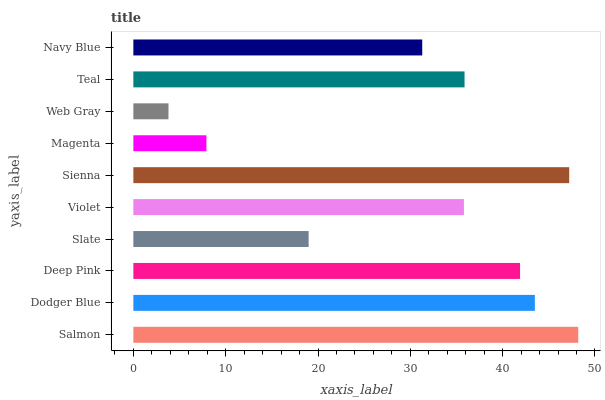Is Web Gray the minimum?
Answer yes or no. Yes. Is Salmon the maximum?
Answer yes or no. Yes. Is Dodger Blue the minimum?
Answer yes or no. No. Is Dodger Blue the maximum?
Answer yes or no. No. Is Salmon greater than Dodger Blue?
Answer yes or no. Yes. Is Dodger Blue less than Salmon?
Answer yes or no. Yes. Is Dodger Blue greater than Salmon?
Answer yes or no. No. Is Salmon less than Dodger Blue?
Answer yes or no. No. Is Teal the high median?
Answer yes or no. Yes. Is Violet the low median?
Answer yes or no. Yes. Is Dodger Blue the high median?
Answer yes or no. No. Is Navy Blue the low median?
Answer yes or no. No. 